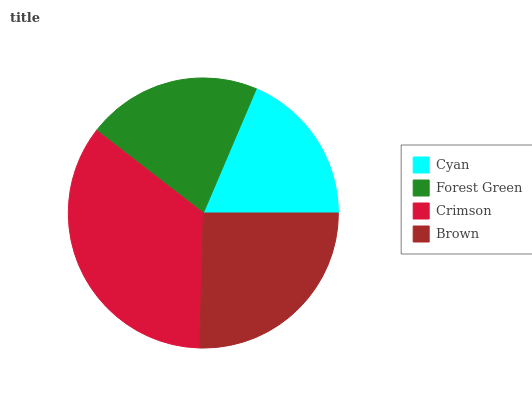Is Cyan the minimum?
Answer yes or no. Yes. Is Crimson the maximum?
Answer yes or no. Yes. Is Forest Green the minimum?
Answer yes or no. No. Is Forest Green the maximum?
Answer yes or no. No. Is Forest Green greater than Cyan?
Answer yes or no. Yes. Is Cyan less than Forest Green?
Answer yes or no. Yes. Is Cyan greater than Forest Green?
Answer yes or no. No. Is Forest Green less than Cyan?
Answer yes or no. No. Is Brown the high median?
Answer yes or no. Yes. Is Forest Green the low median?
Answer yes or no. Yes. Is Crimson the high median?
Answer yes or no. No. Is Brown the low median?
Answer yes or no. No. 